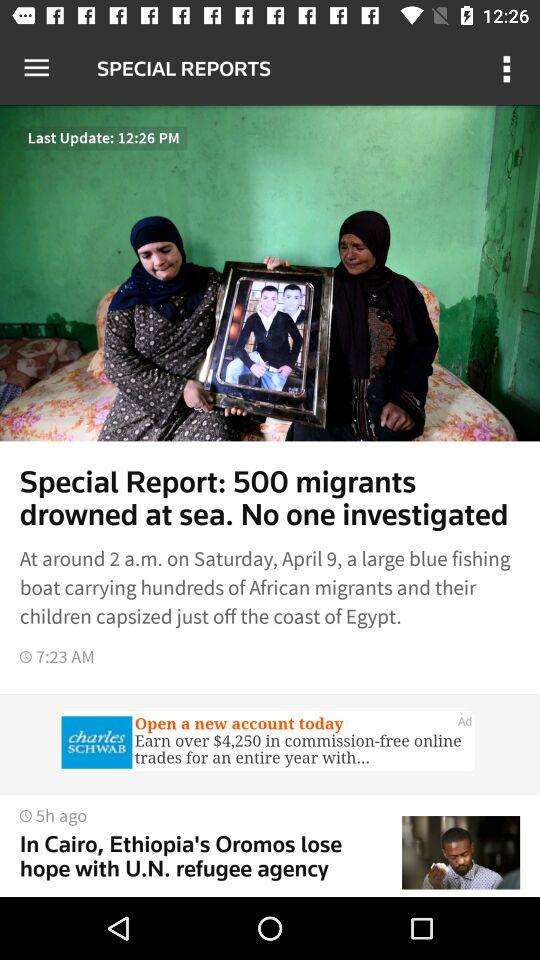How many hours ago was the article published?
Answer the question using a single word or phrase. 5 